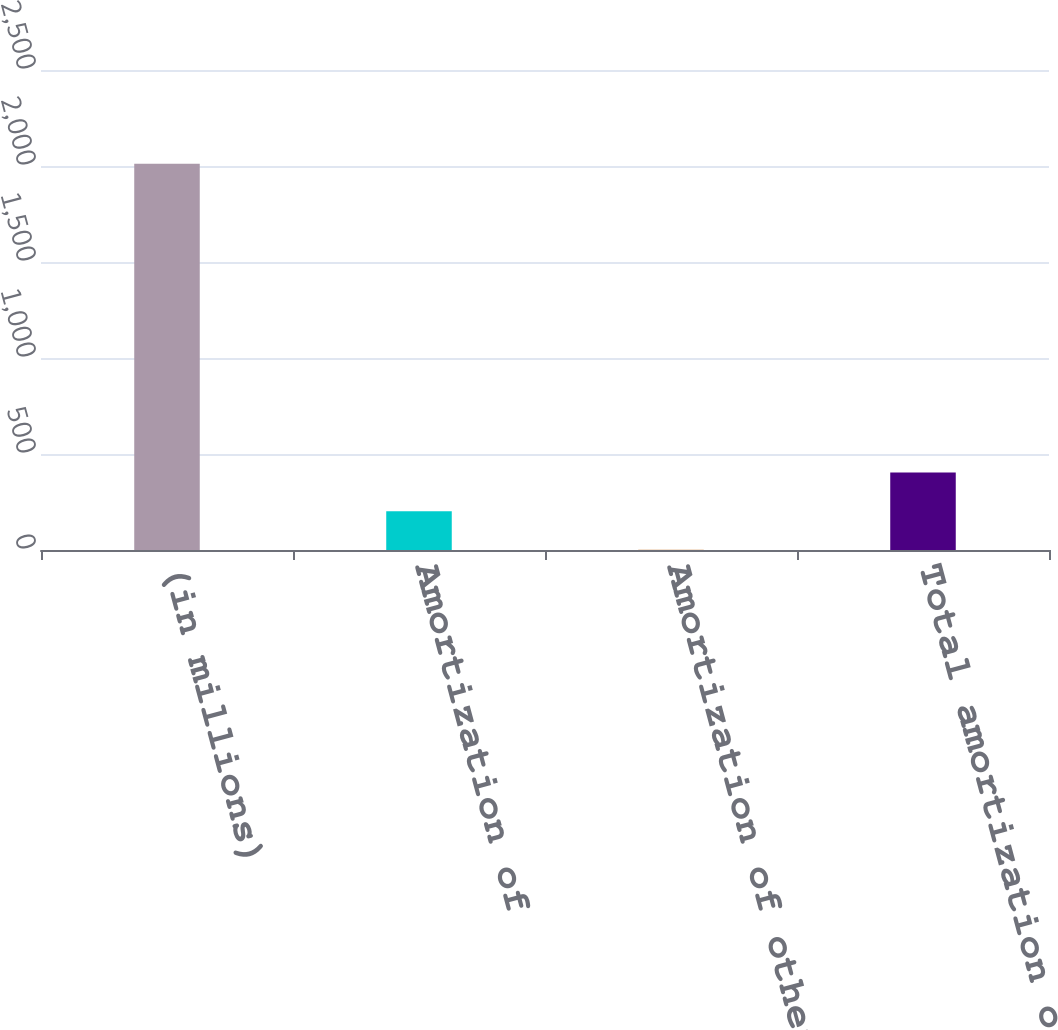Convert chart to OTSL. <chart><loc_0><loc_0><loc_500><loc_500><bar_chart><fcel>(in millions)<fcel>Amortization of<fcel>Amortization of other<fcel>Total amortization of<nl><fcel>2012<fcel>202.1<fcel>1<fcel>403.2<nl></chart> 